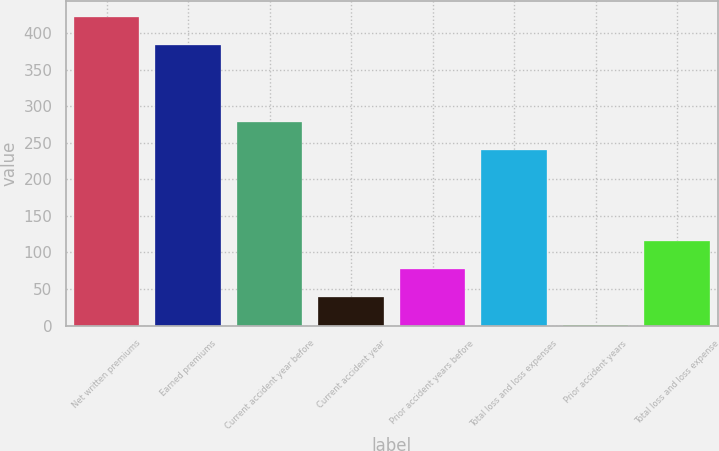<chart> <loc_0><loc_0><loc_500><loc_500><bar_chart><fcel>Net written premiums<fcel>Earned premiums<fcel>Current accident year before<fcel>Current accident year<fcel>Prior accident years before<fcel>Total loss and loss expenses<fcel>Prior accident years<fcel>Total loss and loss expense<nl><fcel>422.47<fcel>384<fcel>278.47<fcel>38.77<fcel>77.24<fcel>240<fcel>0.3<fcel>115.71<nl></chart> 